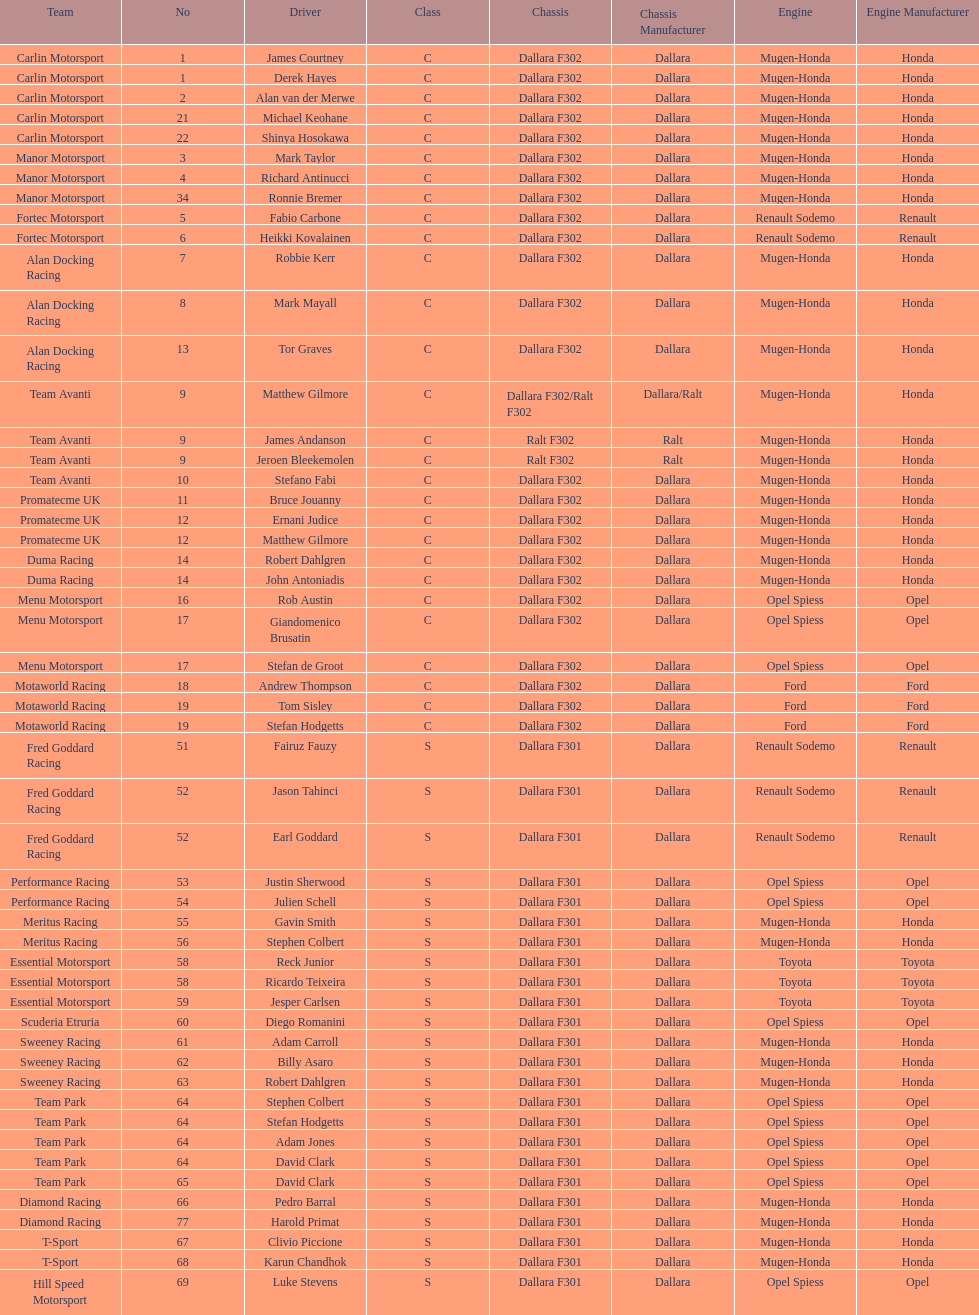What is the total number of class c (championship) teams? 21. 